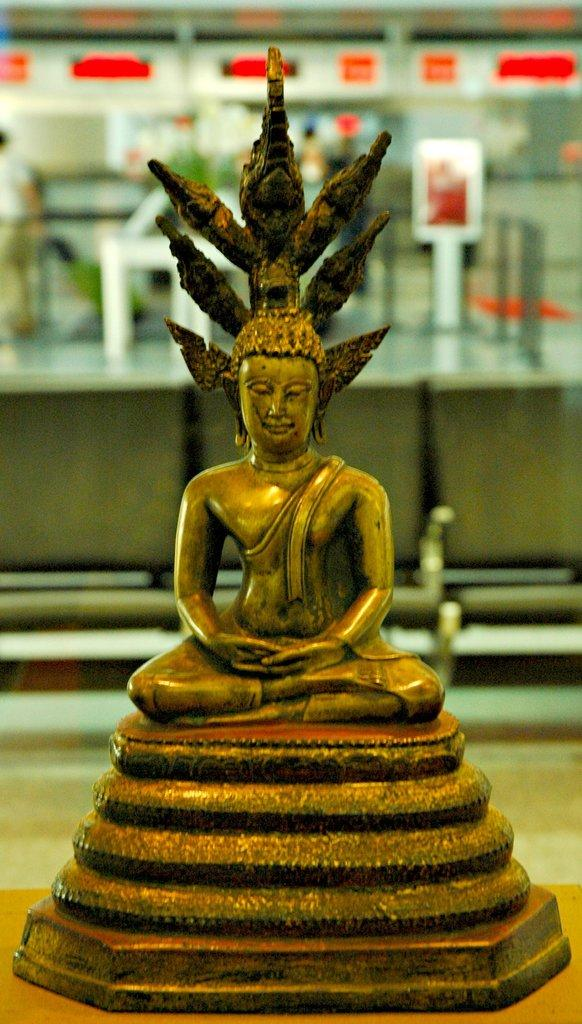What is the main subject of the image? There is a small statue in the image. How many goats are present in the image? There are no goats present in the image; it features a small statue. What type of wealth is depicted in the image? There is no depiction of wealth in the image; it features a small statue. 